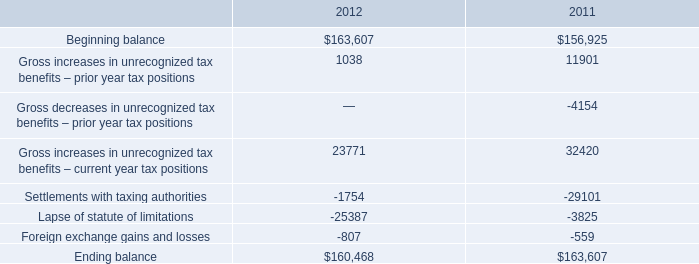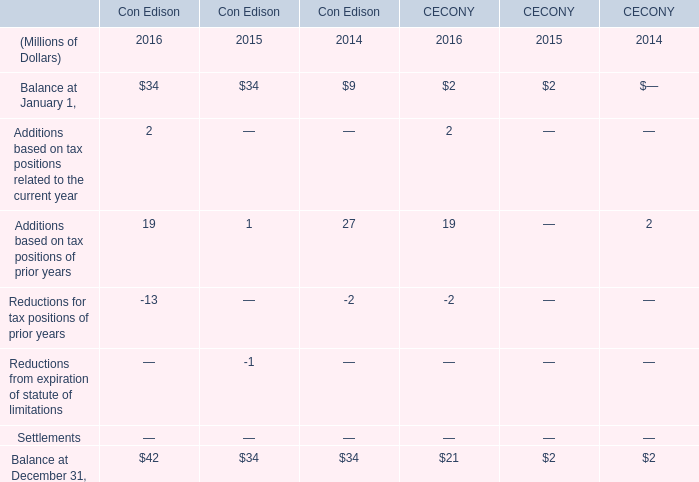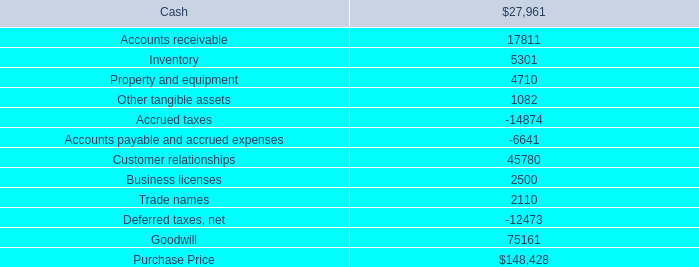What's the current increasing rate of Balance at December 31 in Con Edison? 
Computations: ((42 - 34) / 34)
Answer: 0.23529. 